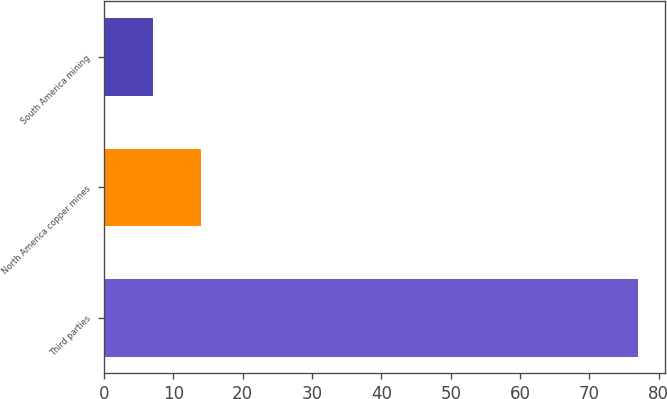Convert chart. <chart><loc_0><loc_0><loc_500><loc_500><bar_chart><fcel>Third parties<fcel>North America copper mines<fcel>South America mining<nl><fcel>77<fcel>14<fcel>7<nl></chart> 